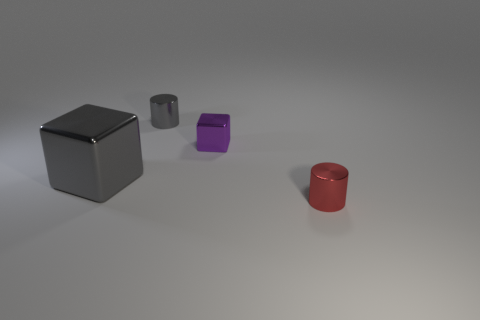Is the shape of the big gray object the same as the tiny purple object?
Offer a very short reply. Yes. What is the gray block made of?
Offer a very short reply. Metal. What number of objects are on the left side of the red thing and on the right side of the gray cube?
Give a very brief answer. 2. Do the gray metal cylinder and the red object have the same size?
Your answer should be compact. Yes. Does the metallic cylinder in front of the gray metallic cylinder have the same size as the tiny gray object?
Provide a short and direct response. Yes. There is a small metallic cylinder that is in front of the small purple metal block; what is its color?
Keep it short and to the point. Red. How many shiny objects are there?
Your answer should be compact. 4. What is the shape of the large gray thing that is the same material as the small gray cylinder?
Provide a short and direct response. Cube. There is a cylinder that is behind the big gray shiny thing; is it the same color as the cube left of the small cube?
Provide a short and direct response. Yes. Is the number of small metallic things to the left of the big gray metal object the same as the number of big gray metal cubes?
Make the answer very short. No. 